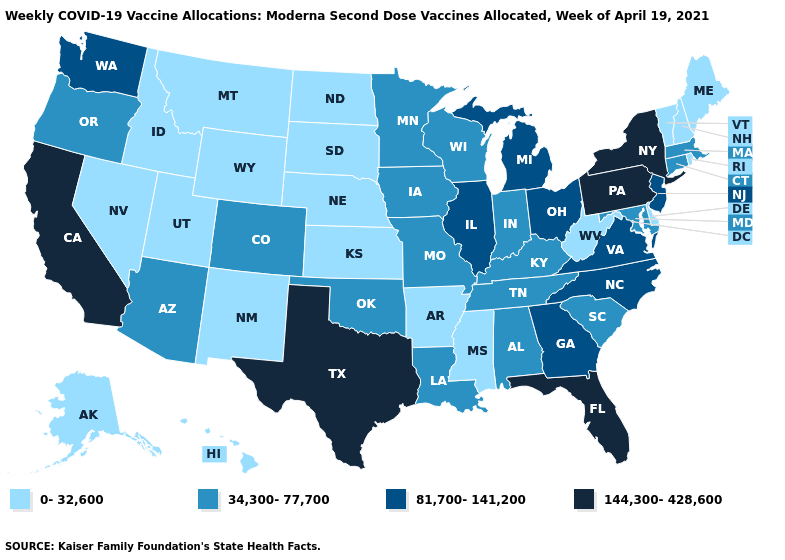What is the value of Minnesota?
Quick response, please. 34,300-77,700. What is the value of Washington?
Be succinct. 81,700-141,200. Name the states that have a value in the range 144,300-428,600?
Keep it brief. California, Florida, New York, Pennsylvania, Texas. Name the states that have a value in the range 81,700-141,200?
Give a very brief answer. Georgia, Illinois, Michigan, New Jersey, North Carolina, Ohio, Virginia, Washington. Among the states that border Oregon , which have the highest value?
Give a very brief answer. California. What is the value of Massachusetts?
Give a very brief answer. 34,300-77,700. Name the states that have a value in the range 81,700-141,200?
Short answer required. Georgia, Illinois, Michigan, New Jersey, North Carolina, Ohio, Virginia, Washington. Which states have the lowest value in the MidWest?
Answer briefly. Kansas, Nebraska, North Dakota, South Dakota. Does Idaho have the lowest value in the West?
Be succinct. Yes. How many symbols are there in the legend?
Keep it brief. 4. Name the states that have a value in the range 0-32,600?
Quick response, please. Alaska, Arkansas, Delaware, Hawaii, Idaho, Kansas, Maine, Mississippi, Montana, Nebraska, Nevada, New Hampshire, New Mexico, North Dakota, Rhode Island, South Dakota, Utah, Vermont, West Virginia, Wyoming. How many symbols are there in the legend?
Answer briefly. 4. Name the states that have a value in the range 144,300-428,600?
Be succinct. California, Florida, New York, Pennsylvania, Texas. Name the states that have a value in the range 34,300-77,700?
Give a very brief answer. Alabama, Arizona, Colorado, Connecticut, Indiana, Iowa, Kentucky, Louisiana, Maryland, Massachusetts, Minnesota, Missouri, Oklahoma, Oregon, South Carolina, Tennessee, Wisconsin. Name the states that have a value in the range 81,700-141,200?
Quick response, please. Georgia, Illinois, Michigan, New Jersey, North Carolina, Ohio, Virginia, Washington. 